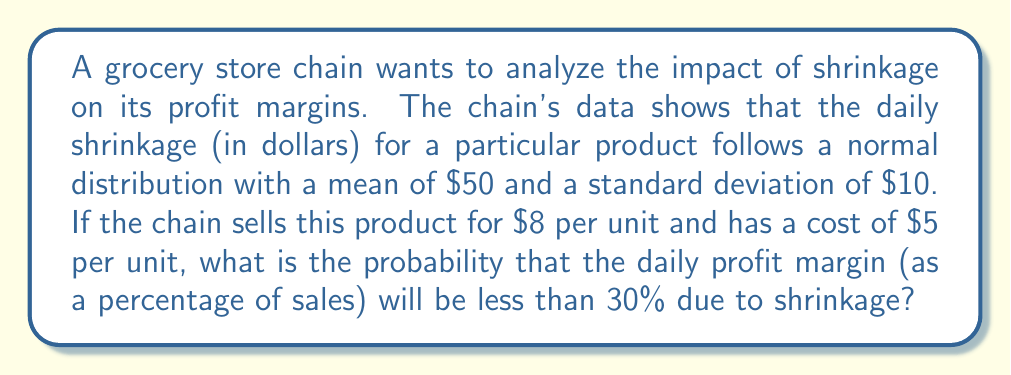Help me with this question. Let's approach this step-by-step:

1) First, we need to define our variables:
   Let X be the daily shrinkage in dollars
   X ~ N($50, 10^2$)

2) We need to find the number of units sold that would result in a 30% profit margin:
   Let n be the number of units sold
   Revenue = $8n
   Cost = $5n + X (product cost plus shrinkage)
   Profit = Revenue - Cost = $8n - ($5n + X) = $3n - X

3) For a 30% profit margin:
   $\frac{Profit}{Revenue} = 0.30$
   $\frac{3n - X}{8n} = 0.30$
   $3n - X = 2.4n$
   $0.6n = X$
   $n = \frac{X}{0.6}$

4) Now, we need to find the probability that X > $0.6n$:
   $P(X > 0.6n) = P(X > 0.6 \cdot \frac{X}{0.6}) = P(X > X) = 0$

5) Therefore, the probability of the profit margin being less than 30% is:
   $P(Margin < 30\%) = 1 - P(Margin \geq 30\%) = 1 - 0 = 1$

This means that regardless of the shrinkage, the profit margin will always be less than 30% given the current pricing structure.

6) To verify, let's calculate the margin without shrinkage:
   Margin = $\frac{8 - 5}{8} = 0.375$ or 37.5%

   With average shrinkage of $50:
   Margin = $\frac{8n - (5n + 50)}{8n} = \frac{3n - 50}{8n}$
   
   This will always be less than 37.5% and thus less than 30% for any positive n.
Answer: 1 (or 100%) 